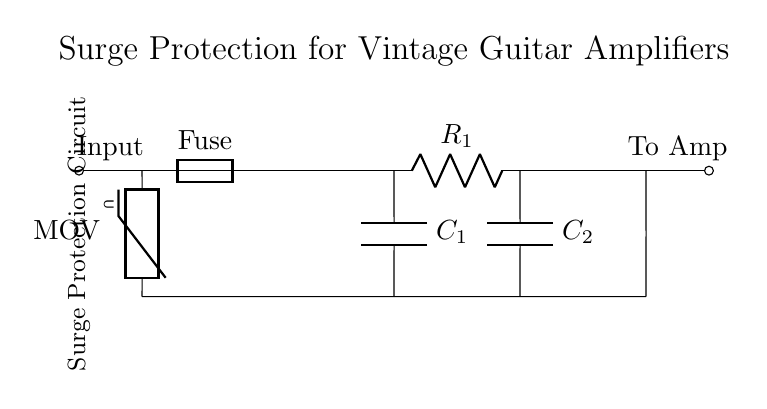What is the main function of the MOV in this circuit? The MOV, or Metal Oxide Varistor, serves to protect the circuit by clamping high-voltage transients and absorbing excess energy in the event of a surge. This helps prevent damage to the vintage guitar amplifier.
Answer: Surge protection What component represents a fuse in the circuit? The fuse is labeled as "Fuse" in the diagram, which is designed to break the circuit in case of overcurrent conditions. This protects downstream components from damage.
Answer: Fuse How many capacitors are present in the circuit? There are two capacitors labeled as C1 and C2 in the circuit, which are used for filtering and stabilization in power supply circuits.
Answer: Two What is the purpose of the resistor R1 in the circuit? Resistor R1 is utilized to limit the current and establish the desired voltage levels across the components in the circuit, thereby providing stability and protecting sensitive components.
Answer: Current limiting What happens if the fuse blows? If the fuse blows, it indicates an overcurrent condition, breaking the circuit and stopping current flow to protect the amplifier from potential damage.
Answer: Circuit interruption Which direction does the current flow after the fuse? Current flows from left to right in the circuit diagram after passing through the fuse, indicating it travels towards the amplifier input.
Answer: Left to right 